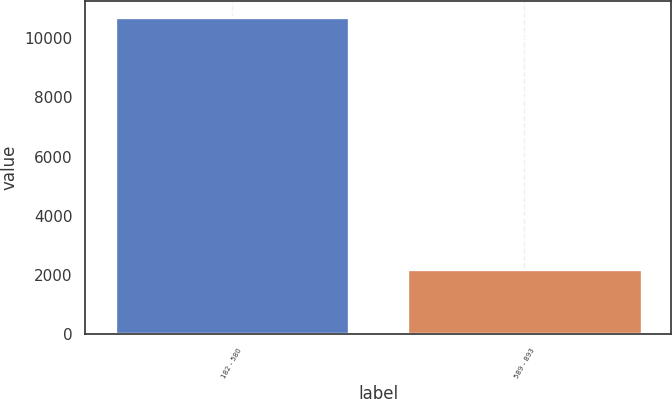<chart> <loc_0><loc_0><loc_500><loc_500><bar_chart><fcel>182 - 580<fcel>589 - 893<nl><fcel>10718<fcel>2213<nl></chart> 